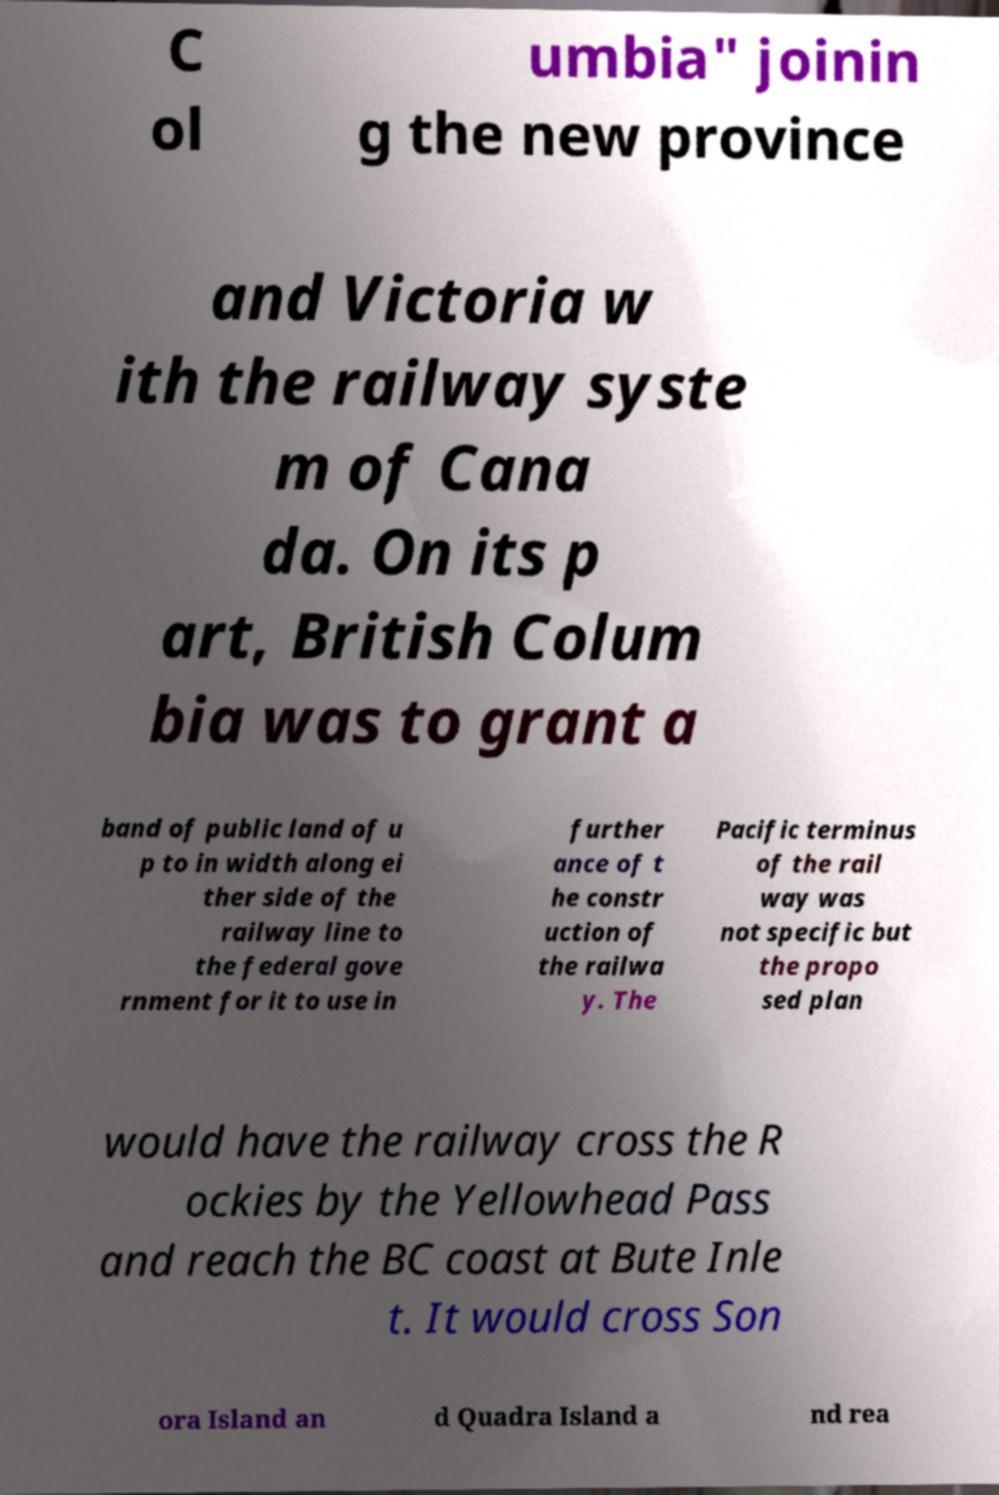Please read and relay the text visible in this image. What does it say? C ol umbia" joinin g the new province and Victoria w ith the railway syste m of Cana da. On its p art, British Colum bia was to grant a band of public land of u p to in width along ei ther side of the railway line to the federal gove rnment for it to use in further ance of t he constr uction of the railwa y. The Pacific terminus of the rail way was not specific but the propo sed plan would have the railway cross the R ockies by the Yellowhead Pass and reach the BC coast at Bute Inle t. It would cross Son ora Island an d Quadra Island a nd rea 